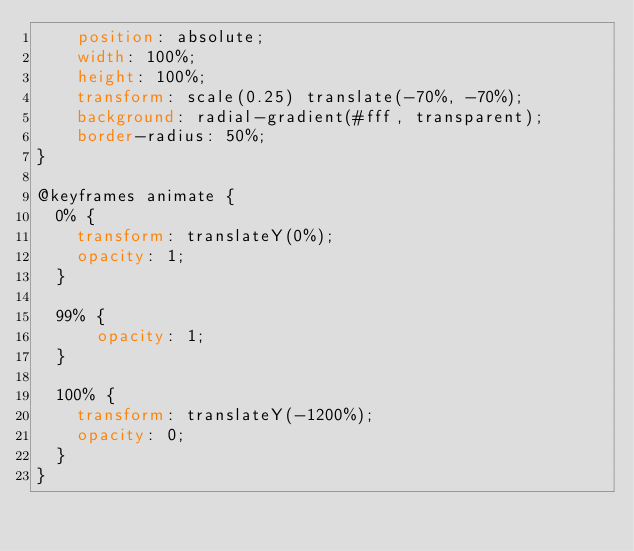Convert code to text. <code><loc_0><loc_0><loc_500><loc_500><_CSS_>    position: absolute;
    width: 100%;
    height: 100%;
    transform: scale(0.25) translate(-70%, -70%);
    background: radial-gradient(#fff, transparent);
    border-radius: 50%;
}

@keyframes animate {
  0% {
    transform: translateY(0%);
    opacity: 1;
  }

  99% {
      opacity: 1;
  }

  100% {
    transform: translateY(-1200%);
    opacity: 0;
  }
}
</code> 